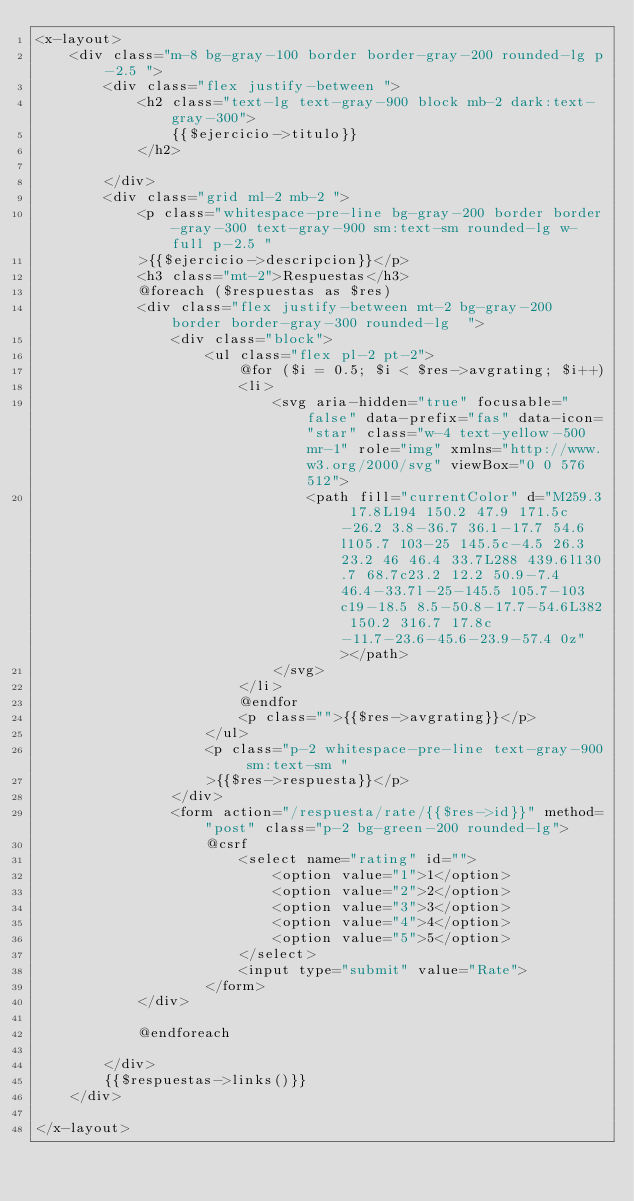<code> <loc_0><loc_0><loc_500><loc_500><_PHP_><x-layout>
    <div class="m-8 bg-gray-100 border border-gray-200 rounded-lg p-2.5 ">
        <div class="flex justify-between ">
            <h2 class="text-lg text-gray-900 block mb-2 dark:text-gray-300">
                {{$ejercicio->titulo}}
            </h2>

        </div>
        <div class="grid ml-2 mb-2 ">
            <p class="whitespace-pre-line bg-gray-200 border border-gray-300 text-gray-900 sm:text-sm rounded-lg w-full p-2.5 "
            >{{$ejercicio->descripcion}}</p>
            <h3 class="mt-2">Respuestas</h3>
            @foreach ($respuestas as $res)
            <div class="flex justify-between mt-2 bg-gray-200 border border-gray-300 rounded-lg  ">
                <div class="block">
                    <ul class="flex pl-2 pt-2">
                        @for ($i = 0.5; $i < $res->avgrating; $i++)
                        <li>
                            <svg aria-hidden="true" focusable="false" data-prefix="fas" data-icon="star" class="w-4 text-yellow-500 mr-1" role="img" xmlns="http://www.w3.org/2000/svg" viewBox="0 0 576 512">
                                <path fill="currentColor" d="M259.3 17.8L194 150.2 47.9 171.5c-26.2 3.8-36.7 36.1-17.7 54.6l105.7 103-25 145.5c-4.5 26.3 23.2 46 46.4 33.7L288 439.6l130.7 68.7c23.2 12.2 50.9-7.4 46.4-33.7l-25-145.5 105.7-103c19-18.5 8.5-50.8-17.7-54.6L382 150.2 316.7 17.8c-11.7-23.6-45.6-23.9-57.4 0z"></path>
                            </svg>
                        </li>
                        @endfor
                        <p class="">{{$res->avgrating}}</p>
                    </ul>
                    <p class="p-2 whitespace-pre-line text-gray-900 sm:text-sm "
                    >{{$res->respuesta}}</p>
                </div>
                <form action="/respuesta/rate/{{$res->id}}" method="post" class="p-2 bg-green-200 rounded-lg">
                    @csrf
                        <select name="rating" id="">
                            <option value="1">1</option>
                            <option value="2">2</option>
                            <option value="3">3</option>
                            <option value="4">4</option>
                            <option value="5">5</option>
                        </select>
                        <input type="submit" value="Rate">
                    </form>
            </div>

            @endforeach

        </div>
        {{$respuestas->links()}}
    </div>

</x-layout>
</code> 